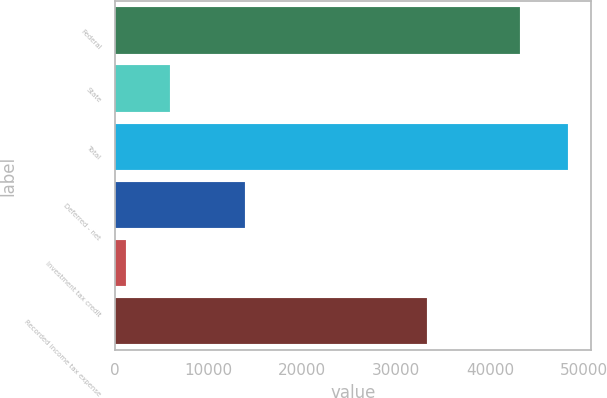Convert chart to OTSL. <chart><loc_0><loc_0><loc_500><loc_500><bar_chart><fcel>Federal<fcel>State<fcel>Total<fcel>Deferred - net<fcel>Investment tax credit<fcel>Recorded income tax expense<nl><fcel>43214<fcel>5870.8<fcel>48313<fcel>13918<fcel>1155<fcel>33240<nl></chart> 